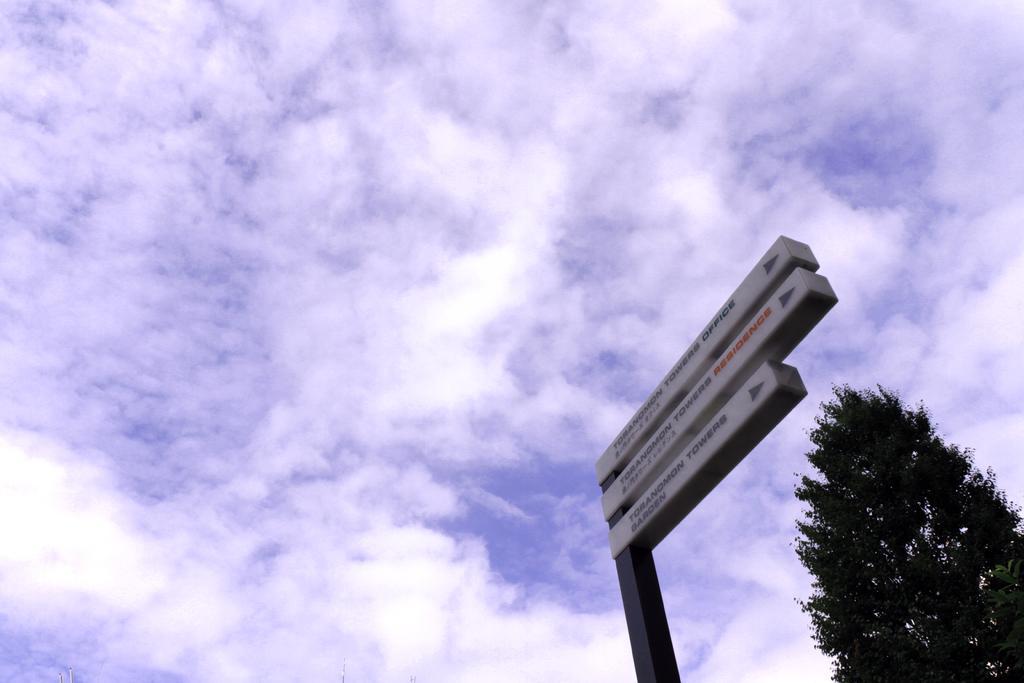In one or two sentences, can you explain what this image depicts? In this image we can see a street sign to a pole. We can also see a tree and the sky which looks cloudy. 